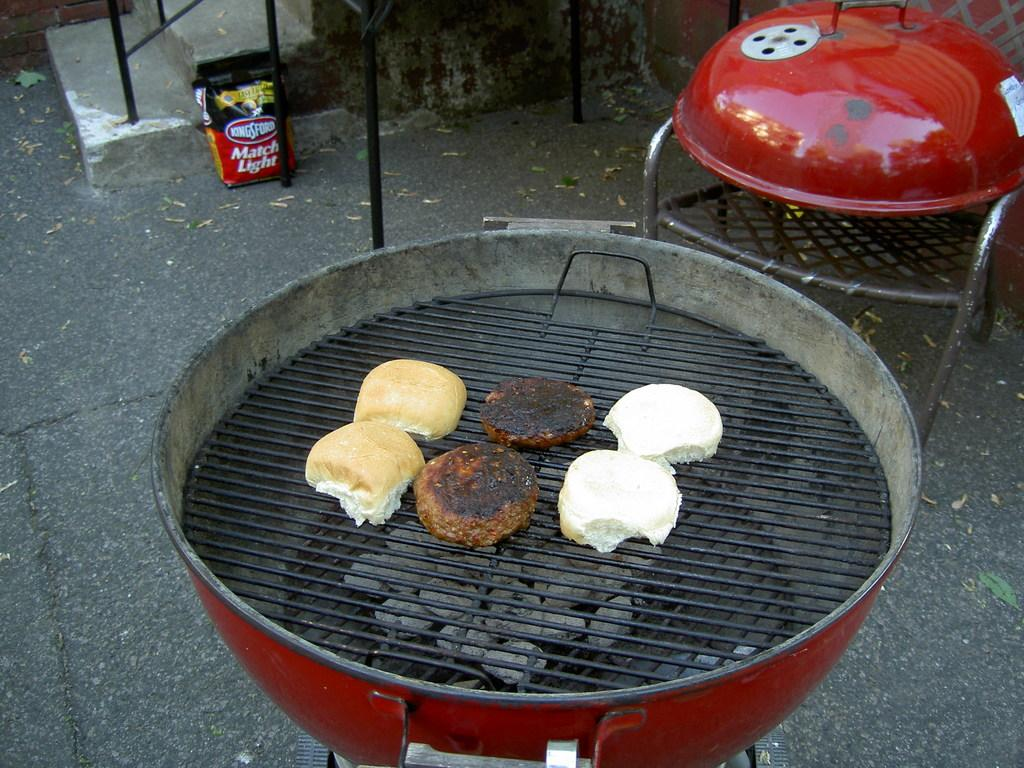<image>
Render a clear and concise summary of the photo. A grill with hamburgers and a bag of charcoal saying Kingsford 